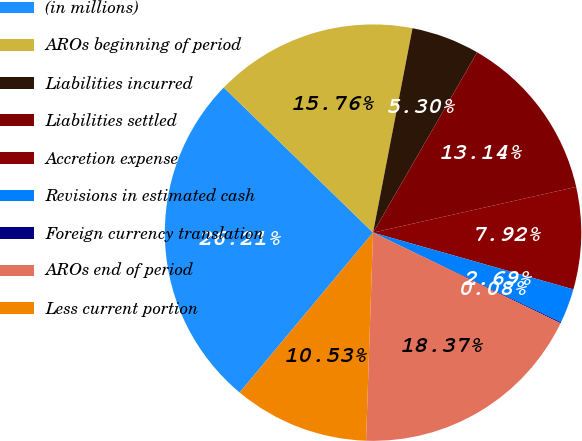Convert chart to OTSL. <chart><loc_0><loc_0><loc_500><loc_500><pie_chart><fcel>(in millions)<fcel>AROs beginning of period<fcel>Liabilities incurred<fcel>Liabilities settled<fcel>Accretion expense<fcel>Revisions in estimated cash<fcel>Foreign currency translation<fcel>AROs end of period<fcel>Less current portion<nl><fcel>26.21%<fcel>15.76%<fcel>5.3%<fcel>13.14%<fcel>7.92%<fcel>2.69%<fcel>0.08%<fcel>18.37%<fcel>10.53%<nl></chart> 